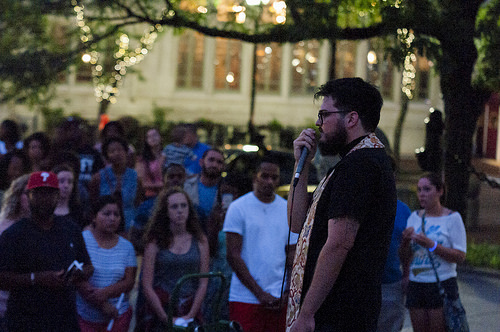<image>
Can you confirm if the man is to the left of the women? Yes. From this viewpoint, the man is positioned to the left side relative to the women. 